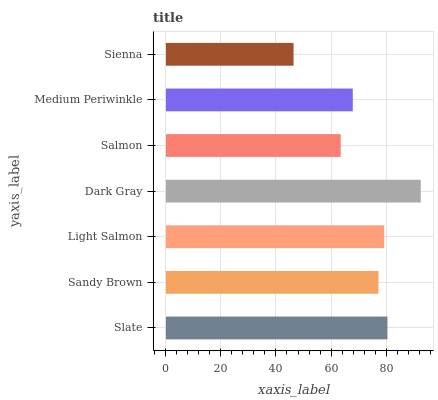Is Sienna the minimum?
Answer yes or no. Yes. Is Dark Gray the maximum?
Answer yes or no. Yes. Is Sandy Brown the minimum?
Answer yes or no. No. Is Sandy Brown the maximum?
Answer yes or no. No. Is Slate greater than Sandy Brown?
Answer yes or no. Yes. Is Sandy Brown less than Slate?
Answer yes or no. Yes. Is Sandy Brown greater than Slate?
Answer yes or no. No. Is Slate less than Sandy Brown?
Answer yes or no. No. Is Sandy Brown the high median?
Answer yes or no. Yes. Is Sandy Brown the low median?
Answer yes or no. Yes. Is Light Salmon the high median?
Answer yes or no. No. Is Medium Periwinkle the low median?
Answer yes or no. No. 